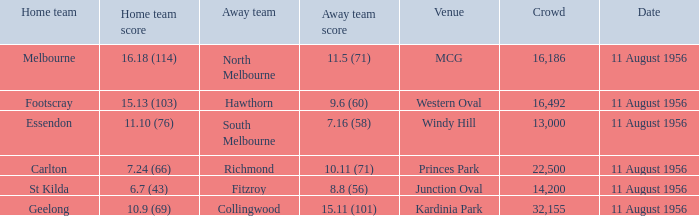What home team has a score of 16.18 (114)? Melbourne. 